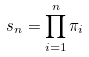<formula> <loc_0><loc_0><loc_500><loc_500>s _ { n } = \prod _ { i = 1 } ^ { n } \pi _ { i }</formula> 